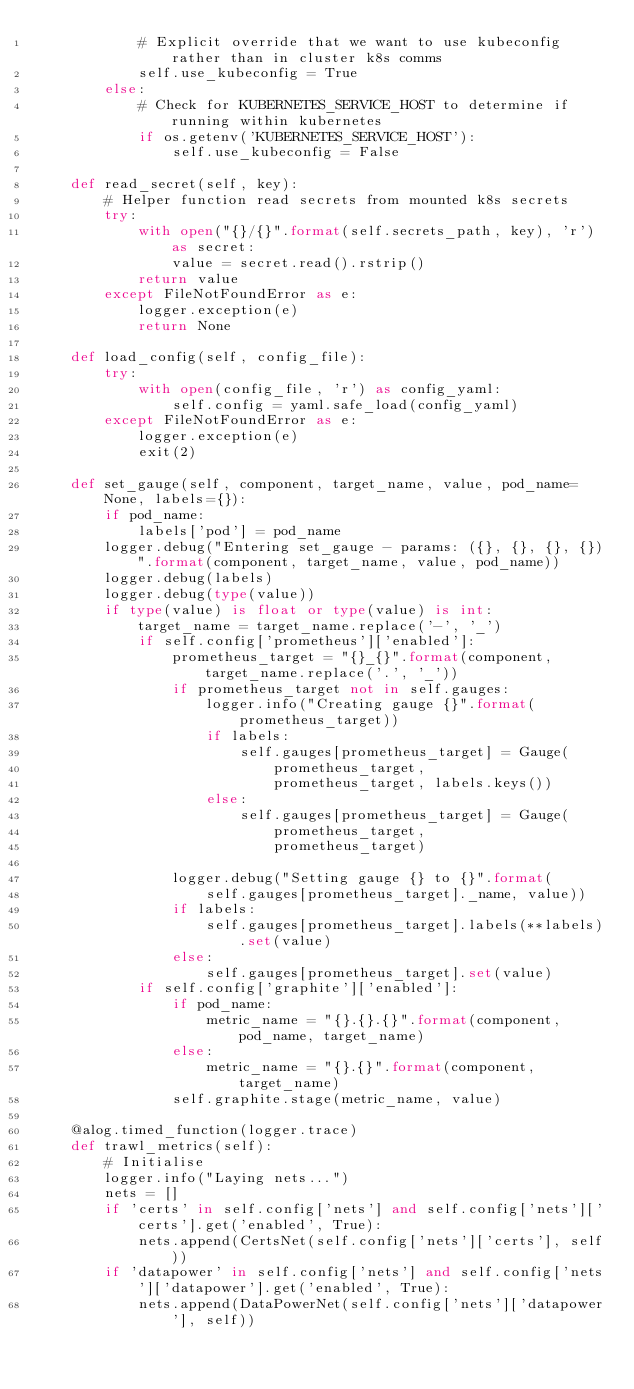<code> <loc_0><loc_0><loc_500><loc_500><_Python_>            # Explicit override that we want to use kubeconfig rather than in cluster k8s comms
            self.use_kubeconfig = True
        else:
            # Check for KUBERNETES_SERVICE_HOST to determine if running within kubernetes
            if os.getenv('KUBERNETES_SERVICE_HOST'):
                self.use_kubeconfig = False

    def read_secret(self, key):
        # Helper function read secrets from mounted k8s secrets
        try:
            with open("{}/{}".format(self.secrets_path, key), 'r') as secret:
                value = secret.read().rstrip()
            return value
        except FileNotFoundError as e:
            logger.exception(e)
            return None

    def load_config(self, config_file):
        try:
            with open(config_file, 'r') as config_yaml:
                self.config = yaml.safe_load(config_yaml)
        except FileNotFoundError as e:
            logger.exception(e)
            exit(2)

    def set_gauge(self, component, target_name, value, pod_name=None, labels={}):
        if pod_name:
            labels['pod'] = pod_name
        logger.debug("Entering set_gauge - params: ({}, {}, {}, {})".format(component, target_name, value, pod_name))
        logger.debug(labels)
        logger.debug(type(value))
        if type(value) is float or type(value) is int:
            target_name = target_name.replace('-', '_')
            if self.config['prometheus']['enabled']:
                prometheus_target = "{}_{}".format(component, target_name.replace('.', '_'))
                if prometheus_target not in self.gauges:
                    logger.info("Creating gauge {}".format(prometheus_target))
                    if labels:
                        self.gauges[prometheus_target] = Gauge(
                            prometheus_target,
                            prometheus_target, labels.keys())
                    else:
                        self.gauges[prometheus_target] = Gauge(
                            prometheus_target,
                            prometheus_target)

                logger.debug("Setting gauge {} to {}".format(
                    self.gauges[prometheus_target]._name, value))
                if labels:
                    self.gauges[prometheus_target].labels(**labels).set(value)
                else:
                    self.gauges[prometheus_target].set(value)
            if self.config['graphite']['enabled']:
                if pod_name:
                    metric_name = "{}.{}.{}".format(component, pod_name, target_name)
                else: 
                    metric_name = "{}.{}".format(component, target_name)
                self.graphite.stage(metric_name, value)

    @alog.timed_function(logger.trace)
    def trawl_metrics(self):
        # Initialise
        logger.info("Laying nets...")
        nets = []
        if 'certs' in self.config['nets'] and self.config['nets']['certs'].get('enabled', True):
            nets.append(CertsNet(self.config['nets']['certs'], self))
        if 'datapower' in self.config['nets'] and self.config['nets']['datapower'].get('enabled', True):
            nets.append(DataPowerNet(self.config['nets']['datapower'], self))</code> 